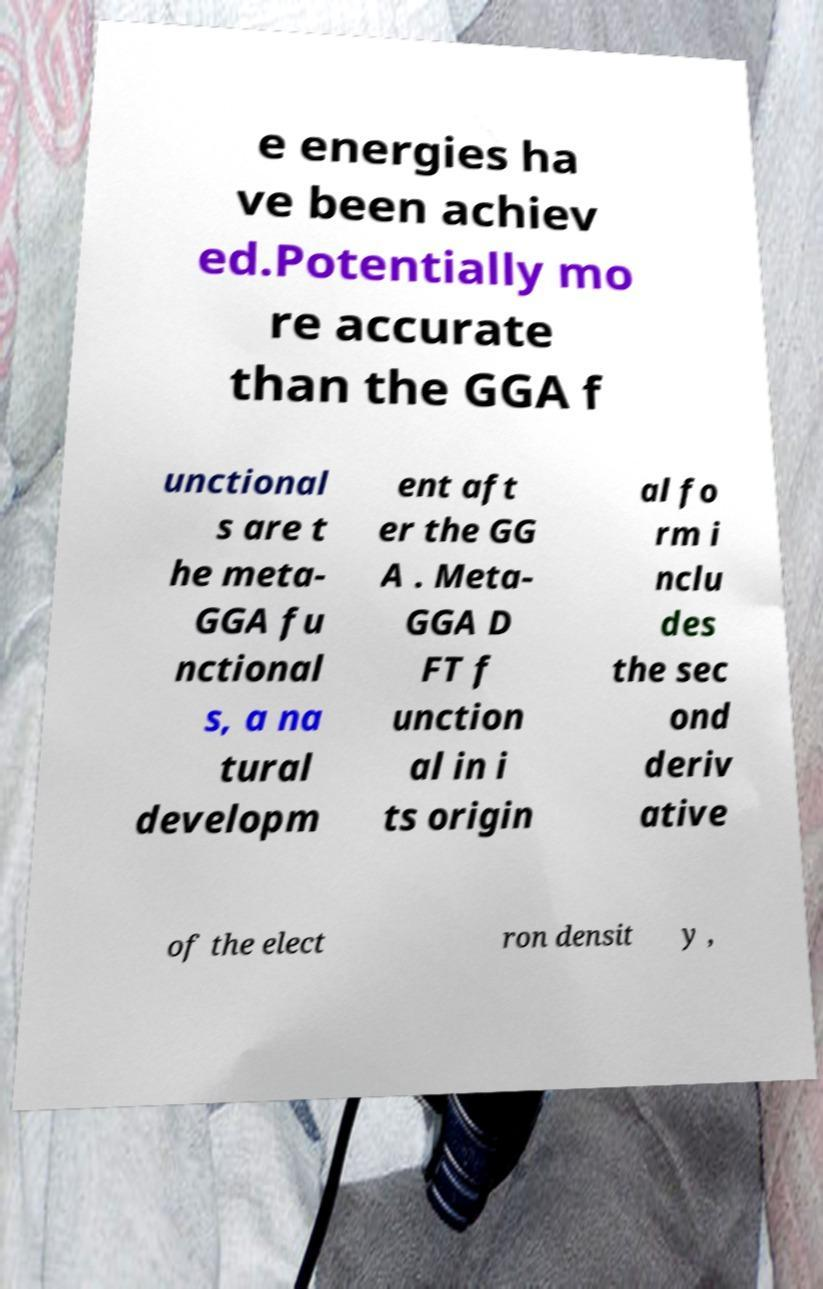Please identify and transcribe the text found in this image. e energies ha ve been achiev ed.Potentially mo re accurate than the GGA f unctional s are t he meta- GGA fu nctional s, a na tural developm ent aft er the GG A . Meta- GGA D FT f unction al in i ts origin al fo rm i nclu des the sec ond deriv ative of the elect ron densit y , 